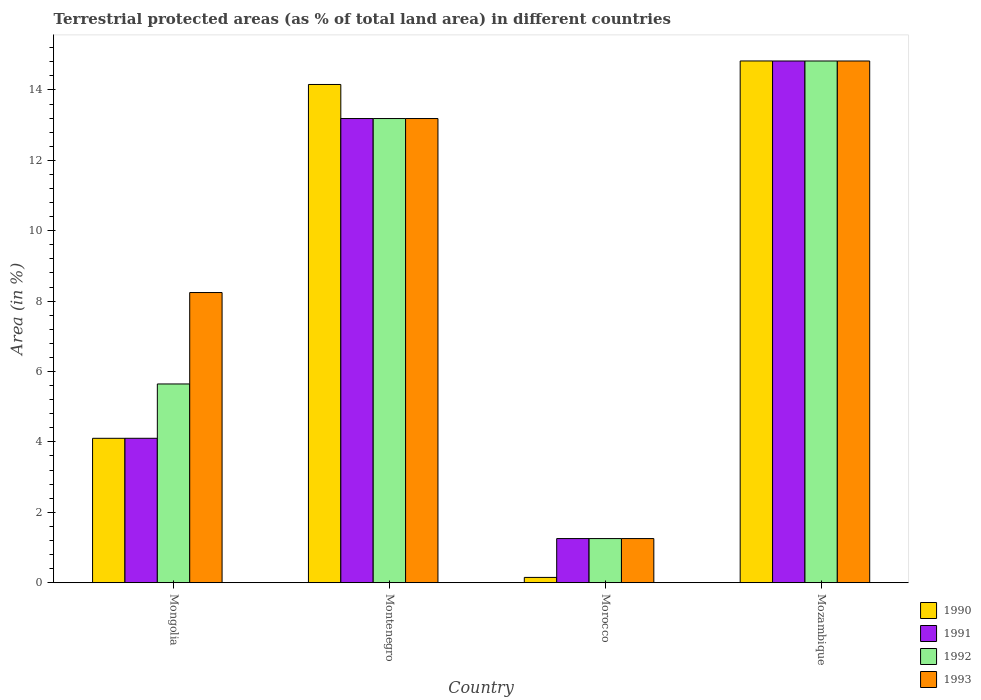How many groups of bars are there?
Offer a terse response. 4. What is the label of the 3rd group of bars from the left?
Your answer should be compact. Morocco. In how many cases, is the number of bars for a given country not equal to the number of legend labels?
Make the answer very short. 0. What is the percentage of terrestrial protected land in 1991 in Mozambique?
Your response must be concise. 14.82. Across all countries, what is the maximum percentage of terrestrial protected land in 1991?
Make the answer very short. 14.82. Across all countries, what is the minimum percentage of terrestrial protected land in 1991?
Keep it short and to the point. 1.25. In which country was the percentage of terrestrial protected land in 1992 maximum?
Provide a succinct answer. Mozambique. In which country was the percentage of terrestrial protected land in 1993 minimum?
Give a very brief answer. Morocco. What is the total percentage of terrestrial protected land in 1992 in the graph?
Provide a succinct answer. 34.91. What is the difference between the percentage of terrestrial protected land in 1990 in Montenegro and that in Morocco?
Provide a short and direct response. 14. What is the difference between the percentage of terrestrial protected land in 1991 in Mongolia and the percentage of terrestrial protected land in 1993 in Montenegro?
Keep it short and to the point. -9.08. What is the average percentage of terrestrial protected land in 1993 per country?
Your response must be concise. 9.38. What is the difference between the percentage of terrestrial protected land of/in 1993 and percentage of terrestrial protected land of/in 1991 in Montenegro?
Your answer should be compact. 0. What is the ratio of the percentage of terrestrial protected land in 1992 in Montenegro to that in Morocco?
Your answer should be compact. 10.52. Is the percentage of terrestrial protected land in 1990 in Montenegro less than that in Morocco?
Your answer should be very brief. No. Is the difference between the percentage of terrestrial protected land in 1993 in Montenegro and Mozambique greater than the difference between the percentage of terrestrial protected land in 1991 in Montenegro and Mozambique?
Make the answer very short. No. What is the difference between the highest and the second highest percentage of terrestrial protected land in 1991?
Your answer should be compact. -9.08. What is the difference between the highest and the lowest percentage of terrestrial protected land in 1990?
Provide a short and direct response. 14.67. In how many countries, is the percentage of terrestrial protected land in 1993 greater than the average percentage of terrestrial protected land in 1993 taken over all countries?
Give a very brief answer. 2. Is the sum of the percentage of terrestrial protected land in 1990 in Mongolia and Morocco greater than the maximum percentage of terrestrial protected land in 1991 across all countries?
Make the answer very short. No. How many bars are there?
Your response must be concise. 16. Are all the bars in the graph horizontal?
Your answer should be very brief. No. Are the values on the major ticks of Y-axis written in scientific E-notation?
Your response must be concise. No. Does the graph contain grids?
Offer a terse response. No. How are the legend labels stacked?
Make the answer very short. Vertical. What is the title of the graph?
Ensure brevity in your answer.  Terrestrial protected areas (as % of total land area) in different countries. Does "1996" appear as one of the legend labels in the graph?
Ensure brevity in your answer.  No. What is the label or title of the X-axis?
Your answer should be very brief. Country. What is the label or title of the Y-axis?
Give a very brief answer. Area (in %). What is the Area (in %) of 1990 in Mongolia?
Your answer should be very brief. 4.1. What is the Area (in %) in 1991 in Mongolia?
Provide a short and direct response. 4.1. What is the Area (in %) in 1992 in Mongolia?
Your response must be concise. 5.65. What is the Area (in %) in 1993 in Mongolia?
Your answer should be very brief. 8.24. What is the Area (in %) of 1990 in Montenegro?
Make the answer very short. 14.15. What is the Area (in %) in 1991 in Montenegro?
Offer a very short reply. 13.19. What is the Area (in %) of 1992 in Montenegro?
Ensure brevity in your answer.  13.19. What is the Area (in %) in 1993 in Montenegro?
Make the answer very short. 13.19. What is the Area (in %) in 1990 in Morocco?
Provide a short and direct response. 0.15. What is the Area (in %) of 1991 in Morocco?
Provide a succinct answer. 1.25. What is the Area (in %) in 1992 in Morocco?
Your answer should be compact. 1.25. What is the Area (in %) in 1993 in Morocco?
Keep it short and to the point. 1.25. What is the Area (in %) in 1990 in Mozambique?
Ensure brevity in your answer.  14.82. What is the Area (in %) in 1991 in Mozambique?
Your response must be concise. 14.82. What is the Area (in %) in 1992 in Mozambique?
Your answer should be very brief. 14.82. What is the Area (in %) of 1993 in Mozambique?
Ensure brevity in your answer.  14.82. Across all countries, what is the maximum Area (in %) of 1990?
Provide a succinct answer. 14.82. Across all countries, what is the maximum Area (in %) in 1991?
Your answer should be very brief. 14.82. Across all countries, what is the maximum Area (in %) in 1992?
Your answer should be very brief. 14.82. Across all countries, what is the maximum Area (in %) of 1993?
Your response must be concise. 14.82. Across all countries, what is the minimum Area (in %) in 1990?
Give a very brief answer. 0.15. Across all countries, what is the minimum Area (in %) of 1991?
Your answer should be very brief. 1.25. Across all countries, what is the minimum Area (in %) in 1992?
Offer a very short reply. 1.25. Across all countries, what is the minimum Area (in %) in 1993?
Ensure brevity in your answer.  1.25. What is the total Area (in %) of 1990 in the graph?
Offer a very short reply. 33.23. What is the total Area (in %) in 1991 in the graph?
Offer a terse response. 33.37. What is the total Area (in %) of 1992 in the graph?
Offer a terse response. 34.91. What is the total Area (in %) in 1993 in the graph?
Keep it short and to the point. 37.51. What is the difference between the Area (in %) in 1990 in Mongolia and that in Montenegro?
Provide a short and direct response. -10.05. What is the difference between the Area (in %) in 1991 in Mongolia and that in Montenegro?
Your response must be concise. -9.08. What is the difference between the Area (in %) in 1992 in Mongolia and that in Montenegro?
Your answer should be very brief. -7.54. What is the difference between the Area (in %) of 1993 in Mongolia and that in Montenegro?
Your answer should be compact. -4.94. What is the difference between the Area (in %) of 1990 in Mongolia and that in Morocco?
Give a very brief answer. 3.95. What is the difference between the Area (in %) of 1991 in Mongolia and that in Morocco?
Provide a short and direct response. 2.85. What is the difference between the Area (in %) of 1992 in Mongolia and that in Morocco?
Your answer should be compact. 4.39. What is the difference between the Area (in %) in 1993 in Mongolia and that in Morocco?
Give a very brief answer. 6.99. What is the difference between the Area (in %) in 1990 in Mongolia and that in Mozambique?
Your answer should be compact. -10.72. What is the difference between the Area (in %) of 1991 in Mongolia and that in Mozambique?
Ensure brevity in your answer.  -10.72. What is the difference between the Area (in %) in 1992 in Mongolia and that in Mozambique?
Keep it short and to the point. -9.18. What is the difference between the Area (in %) of 1993 in Mongolia and that in Mozambique?
Your answer should be compact. -6.58. What is the difference between the Area (in %) of 1990 in Montenegro and that in Morocco?
Your response must be concise. 14. What is the difference between the Area (in %) of 1991 in Montenegro and that in Morocco?
Provide a succinct answer. 11.93. What is the difference between the Area (in %) in 1992 in Montenegro and that in Morocco?
Give a very brief answer. 11.93. What is the difference between the Area (in %) in 1993 in Montenegro and that in Morocco?
Ensure brevity in your answer.  11.93. What is the difference between the Area (in %) of 1990 in Montenegro and that in Mozambique?
Provide a succinct answer. -0.67. What is the difference between the Area (in %) in 1991 in Montenegro and that in Mozambique?
Offer a very short reply. -1.64. What is the difference between the Area (in %) in 1992 in Montenegro and that in Mozambique?
Provide a succinct answer. -1.64. What is the difference between the Area (in %) of 1993 in Montenegro and that in Mozambique?
Your answer should be very brief. -1.64. What is the difference between the Area (in %) of 1990 in Morocco and that in Mozambique?
Your answer should be compact. -14.67. What is the difference between the Area (in %) of 1991 in Morocco and that in Mozambique?
Your response must be concise. -13.57. What is the difference between the Area (in %) of 1992 in Morocco and that in Mozambique?
Keep it short and to the point. -13.57. What is the difference between the Area (in %) of 1993 in Morocco and that in Mozambique?
Ensure brevity in your answer.  -13.57. What is the difference between the Area (in %) of 1990 in Mongolia and the Area (in %) of 1991 in Montenegro?
Keep it short and to the point. -9.08. What is the difference between the Area (in %) in 1990 in Mongolia and the Area (in %) in 1992 in Montenegro?
Keep it short and to the point. -9.08. What is the difference between the Area (in %) of 1990 in Mongolia and the Area (in %) of 1993 in Montenegro?
Offer a terse response. -9.08. What is the difference between the Area (in %) in 1991 in Mongolia and the Area (in %) in 1992 in Montenegro?
Ensure brevity in your answer.  -9.08. What is the difference between the Area (in %) of 1991 in Mongolia and the Area (in %) of 1993 in Montenegro?
Offer a terse response. -9.08. What is the difference between the Area (in %) of 1992 in Mongolia and the Area (in %) of 1993 in Montenegro?
Provide a succinct answer. -7.54. What is the difference between the Area (in %) of 1990 in Mongolia and the Area (in %) of 1991 in Morocco?
Give a very brief answer. 2.85. What is the difference between the Area (in %) in 1990 in Mongolia and the Area (in %) in 1992 in Morocco?
Ensure brevity in your answer.  2.85. What is the difference between the Area (in %) in 1990 in Mongolia and the Area (in %) in 1993 in Morocco?
Keep it short and to the point. 2.85. What is the difference between the Area (in %) of 1991 in Mongolia and the Area (in %) of 1992 in Morocco?
Ensure brevity in your answer.  2.85. What is the difference between the Area (in %) in 1991 in Mongolia and the Area (in %) in 1993 in Morocco?
Offer a very short reply. 2.85. What is the difference between the Area (in %) in 1992 in Mongolia and the Area (in %) in 1993 in Morocco?
Your answer should be very brief. 4.39. What is the difference between the Area (in %) in 1990 in Mongolia and the Area (in %) in 1991 in Mozambique?
Your answer should be compact. -10.72. What is the difference between the Area (in %) of 1990 in Mongolia and the Area (in %) of 1992 in Mozambique?
Provide a short and direct response. -10.72. What is the difference between the Area (in %) of 1990 in Mongolia and the Area (in %) of 1993 in Mozambique?
Offer a very short reply. -10.72. What is the difference between the Area (in %) in 1991 in Mongolia and the Area (in %) in 1992 in Mozambique?
Your response must be concise. -10.72. What is the difference between the Area (in %) in 1991 in Mongolia and the Area (in %) in 1993 in Mozambique?
Your response must be concise. -10.72. What is the difference between the Area (in %) in 1992 in Mongolia and the Area (in %) in 1993 in Mozambique?
Make the answer very short. -9.18. What is the difference between the Area (in %) in 1990 in Montenegro and the Area (in %) in 1991 in Morocco?
Offer a very short reply. 12.9. What is the difference between the Area (in %) in 1990 in Montenegro and the Area (in %) in 1992 in Morocco?
Provide a succinct answer. 12.9. What is the difference between the Area (in %) in 1990 in Montenegro and the Area (in %) in 1993 in Morocco?
Offer a terse response. 12.9. What is the difference between the Area (in %) in 1991 in Montenegro and the Area (in %) in 1992 in Morocco?
Offer a very short reply. 11.93. What is the difference between the Area (in %) of 1991 in Montenegro and the Area (in %) of 1993 in Morocco?
Provide a succinct answer. 11.93. What is the difference between the Area (in %) of 1992 in Montenegro and the Area (in %) of 1993 in Morocco?
Your answer should be very brief. 11.93. What is the difference between the Area (in %) of 1990 in Montenegro and the Area (in %) of 1991 in Mozambique?
Make the answer very short. -0.67. What is the difference between the Area (in %) in 1990 in Montenegro and the Area (in %) in 1992 in Mozambique?
Your answer should be compact. -0.67. What is the difference between the Area (in %) in 1990 in Montenegro and the Area (in %) in 1993 in Mozambique?
Keep it short and to the point. -0.67. What is the difference between the Area (in %) in 1991 in Montenegro and the Area (in %) in 1992 in Mozambique?
Provide a succinct answer. -1.64. What is the difference between the Area (in %) of 1991 in Montenegro and the Area (in %) of 1993 in Mozambique?
Offer a terse response. -1.64. What is the difference between the Area (in %) of 1992 in Montenegro and the Area (in %) of 1993 in Mozambique?
Make the answer very short. -1.64. What is the difference between the Area (in %) of 1990 in Morocco and the Area (in %) of 1991 in Mozambique?
Ensure brevity in your answer.  -14.67. What is the difference between the Area (in %) in 1990 in Morocco and the Area (in %) in 1992 in Mozambique?
Your answer should be very brief. -14.67. What is the difference between the Area (in %) of 1990 in Morocco and the Area (in %) of 1993 in Mozambique?
Keep it short and to the point. -14.67. What is the difference between the Area (in %) in 1991 in Morocco and the Area (in %) in 1992 in Mozambique?
Provide a short and direct response. -13.57. What is the difference between the Area (in %) in 1991 in Morocco and the Area (in %) in 1993 in Mozambique?
Provide a short and direct response. -13.57. What is the difference between the Area (in %) of 1992 in Morocco and the Area (in %) of 1993 in Mozambique?
Offer a very short reply. -13.57. What is the average Area (in %) in 1990 per country?
Provide a short and direct response. 8.31. What is the average Area (in %) of 1991 per country?
Provide a short and direct response. 8.34. What is the average Area (in %) in 1992 per country?
Ensure brevity in your answer.  8.73. What is the average Area (in %) in 1993 per country?
Give a very brief answer. 9.38. What is the difference between the Area (in %) of 1990 and Area (in %) of 1991 in Mongolia?
Offer a terse response. -0. What is the difference between the Area (in %) in 1990 and Area (in %) in 1992 in Mongolia?
Your answer should be very brief. -1.54. What is the difference between the Area (in %) in 1990 and Area (in %) in 1993 in Mongolia?
Make the answer very short. -4.14. What is the difference between the Area (in %) of 1991 and Area (in %) of 1992 in Mongolia?
Provide a short and direct response. -1.54. What is the difference between the Area (in %) in 1991 and Area (in %) in 1993 in Mongolia?
Offer a terse response. -4.14. What is the difference between the Area (in %) in 1992 and Area (in %) in 1993 in Mongolia?
Your answer should be very brief. -2.6. What is the difference between the Area (in %) of 1990 and Area (in %) of 1992 in Montenegro?
Provide a succinct answer. 0.97. What is the difference between the Area (in %) in 1992 and Area (in %) in 1993 in Montenegro?
Your answer should be compact. 0. What is the difference between the Area (in %) in 1990 and Area (in %) in 1991 in Morocco?
Provide a succinct answer. -1.1. What is the difference between the Area (in %) in 1990 and Area (in %) in 1992 in Morocco?
Your answer should be very brief. -1.1. What is the difference between the Area (in %) of 1990 and Area (in %) of 1993 in Morocco?
Provide a short and direct response. -1.1. What is the difference between the Area (in %) in 1990 and Area (in %) in 1991 in Mozambique?
Your answer should be very brief. 0. What is the difference between the Area (in %) in 1990 and Area (in %) in 1992 in Mozambique?
Ensure brevity in your answer.  0. What is the difference between the Area (in %) of 1990 and Area (in %) of 1993 in Mozambique?
Keep it short and to the point. 0. What is the difference between the Area (in %) of 1991 and Area (in %) of 1993 in Mozambique?
Offer a terse response. 0. What is the ratio of the Area (in %) of 1990 in Mongolia to that in Montenegro?
Make the answer very short. 0.29. What is the ratio of the Area (in %) of 1991 in Mongolia to that in Montenegro?
Provide a succinct answer. 0.31. What is the ratio of the Area (in %) in 1992 in Mongolia to that in Montenegro?
Make the answer very short. 0.43. What is the ratio of the Area (in %) in 1993 in Mongolia to that in Montenegro?
Keep it short and to the point. 0.63. What is the ratio of the Area (in %) of 1990 in Mongolia to that in Morocco?
Make the answer very short. 27.28. What is the ratio of the Area (in %) in 1991 in Mongolia to that in Morocco?
Provide a succinct answer. 3.27. What is the ratio of the Area (in %) in 1992 in Mongolia to that in Morocco?
Offer a terse response. 4.5. What is the ratio of the Area (in %) in 1993 in Mongolia to that in Morocco?
Keep it short and to the point. 6.57. What is the ratio of the Area (in %) in 1990 in Mongolia to that in Mozambique?
Keep it short and to the point. 0.28. What is the ratio of the Area (in %) in 1991 in Mongolia to that in Mozambique?
Offer a terse response. 0.28. What is the ratio of the Area (in %) in 1992 in Mongolia to that in Mozambique?
Provide a succinct answer. 0.38. What is the ratio of the Area (in %) in 1993 in Mongolia to that in Mozambique?
Give a very brief answer. 0.56. What is the ratio of the Area (in %) in 1990 in Montenegro to that in Morocco?
Your answer should be compact. 94.12. What is the ratio of the Area (in %) of 1991 in Montenegro to that in Morocco?
Ensure brevity in your answer.  10.52. What is the ratio of the Area (in %) in 1992 in Montenegro to that in Morocco?
Offer a very short reply. 10.52. What is the ratio of the Area (in %) in 1993 in Montenegro to that in Morocco?
Give a very brief answer. 10.52. What is the ratio of the Area (in %) of 1990 in Montenegro to that in Mozambique?
Offer a very short reply. 0.95. What is the ratio of the Area (in %) of 1991 in Montenegro to that in Mozambique?
Provide a short and direct response. 0.89. What is the ratio of the Area (in %) of 1992 in Montenegro to that in Mozambique?
Your response must be concise. 0.89. What is the ratio of the Area (in %) of 1993 in Montenegro to that in Mozambique?
Offer a very short reply. 0.89. What is the ratio of the Area (in %) in 1990 in Morocco to that in Mozambique?
Offer a very short reply. 0.01. What is the ratio of the Area (in %) of 1991 in Morocco to that in Mozambique?
Offer a terse response. 0.08. What is the ratio of the Area (in %) in 1992 in Morocco to that in Mozambique?
Offer a very short reply. 0.08. What is the ratio of the Area (in %) of 1993 in Morocco to that in Mozambique?
Your answer should be very brief. 0.08. What is the difference between the highest and the second highest Area (in %) of 1990?
Offer a terse response. 0.67. What is the difference between the highest and the second highest Area (in %) of 1991?
Offer a terse response. 1.64. What is the difference between the highest and the second highest Area (in %) in 1992?
Keep it short and to the point. 1.64. What is the difference between the highest and the second highest Area (in %) of 1993?
Make the answer very short. 1.64. What is the difference between the highest and the lowest Area (in %) in 1990?
Ensure brevity in your answer.  14.67. What is the difference between the highest and the lowest Area (in %) in 1991?
Ensure brevity in your answer.  13.57. What is the difference between the highest and the lowest Area (in %) of 1992?
Keep it short and to the point. 13.57. What is the difference between the highest and the lowest Area (in %) in 1993?
Your answer should be very brief. 13.57. 